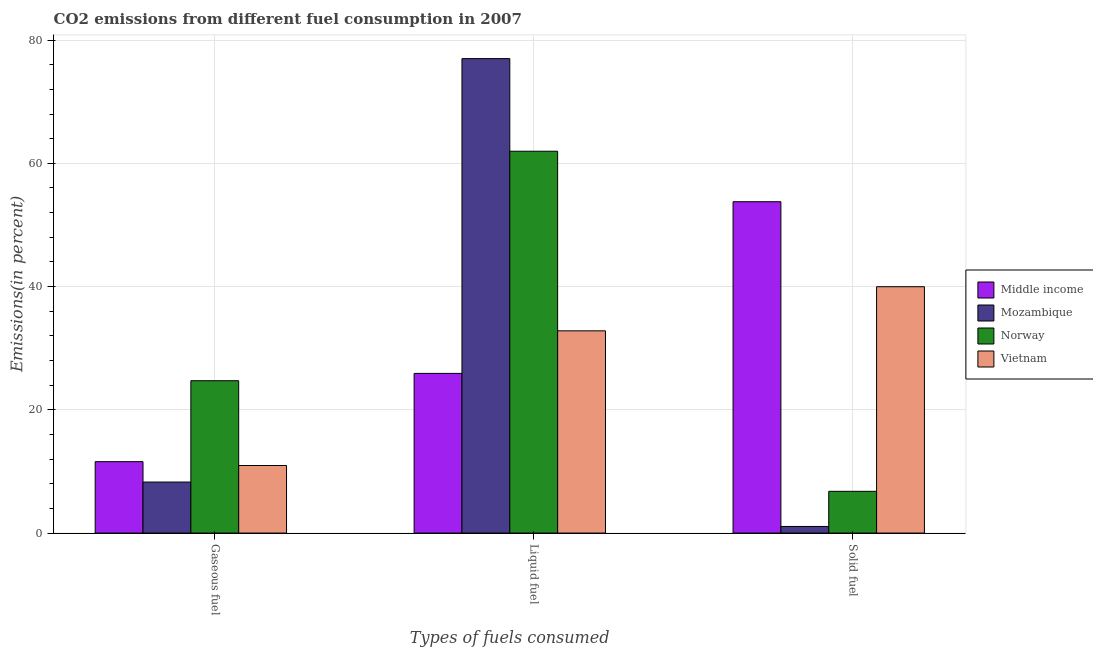How many different coloured bars are there?
Provide a succinct answer. 4. Are the number of bars on each tick of the X-axis equal?
Your answer should be compact. Yes. How many bars are there on the 2nd tick from the right?
Ensure brevity in your answer.  4. What is the label of the 1st group of bars from the left?
Offer a very short reply. Gaseous fuel. What is the percentage of liquid fuel emission in Middle income?
Your response must be concise. 25.91. Across all countries, what is the maximum percentage of liquid fuel emission?
Your answer should be very brief. 76.99. Across all countries, what is the minimum percentage of gaseous fuel emission?
Your response must be concise. 8.28. In which country was the percentage of solid fuel emission minimum?
Make the answer very short. Mozambique. What is the total percentage of gaseous fuel emission in the graph?
Give a very brief answer. 55.56. What is the difference between the percentage of solid fuel emission in Mozambique and that in Norway?
Offer a very short reply. -5.7. What is the difference between the percentage of solid fuel emission in Mozambique and the percentage of gaseous fuel emission in Vietnam?
Your answer should be compact. -9.89. What is the average percentage of liquid fuel emission per country?
Your answer should be compact. 49.42. What is the difference between the percentage of liquid fuel emission and percentage of gaseous fuel emission in Middle income?
Offer a very short reply. 14.32. In how many countries, is the percentage of solid fuel emission greater than 52 %?
Ensure brevity in your answer.  1. What is the ratio of the percentage of liquid fuel emission in Norway to that in Middle income?
Offer a terse response. 2.39. Is the percentage of liquid fuel emission in Middle income less than that in Mozambique?
Your answer should be very brief. Yes. Is the difference between the percentage of liquid fuel emission in Vietnam and Middle income greater than the difference between the percentage of solid fuel emission in Vietnam and Middle income?
Keep it short and to the point. Yes. What is the difference between the highest and the second highest percentage of gaseous fuel emission?
Offer a very short reply. 13.14. What is the difference between the highest and the lowest percentage of solid fuel emission?
Make the answer very short. 52.7. In how many countries, is the percentage of solid fuel emission greater than the average percentage of solid fuel emission taken over all countries?
Make the answer very short. 2. What does the 2nd bar from the left in Liquid fuel represents?
Your response must be concise. Mozambique. What does the 1st bar from the right in Gaseous fuel represents?
Ensure brevity in your answer.  Vietnam. Is it the case that in every country, the sum of the percentage of gaseous fuel emission and percentage of liquid fuel emission is greater than the percentage of solid fuel emission?
Your answer should be compact. No. How many bars are there?
Offer a terse response. 12. Are all the bars in the graph horizontal?
Make the answer very short. No. How many countries are there in the graph?
Ensure brevity in your answer.  4. What is the difference between two consecutive major ticks on the Y-axis?
Offer a terse response. 20. Does the graph contain any zero values?
Your answer should be very brief. No. Where does the legend appear in the graph?
Offer a very short reply. Center right. How many legend labels are there?
Your answer should be very brief. 4. How are the legend labels stacked?
Keep it short and to the point. Vertical. What is the title of the graph?
Provide a short and direct response. CO2 emissions from different fuel consumption in 2007. Does "China" appear as one of the legend labels in the graph?
Provide a short and direct response. No. What is the label or title of the X-axis?
Your response must be concise. Types of fuels consumed. What is the label or title of the Y-axis?
Provide a succinct answer. Emissions(in percent). What is the Emissions(in percent) of Middle income in Gaseous fuel?
Provide a succinct answer. 11.59. What is the Emissions(in percent) of Mozambique in Gaseous fuel?
Ensure brevity in your answer.  8.28. What is the Emissions(in percent) in Norway in Gaseous fuel?
Ensure brevity in your answer.  24.72. What is the Emissions(in percent) in Vietnam in Gaseous fuel?
Give a very brief answer. 10.96. What is the Emissions(in percent) of Middle income in Liquid fuel?
Provide a succinct answer. 25.91. What is the Emissions(in percent) in Mozambique in Liquid fuel?
Provide a succinct answer. 76.99. What is the Emissions(in percent) in Norway in Liquid fuel?
Your answer should be very brief. 61.96. What is the Emissions(in percent) in Vietnam in Liquid fuel?
Your answer should be compact. 32.82. What is the Emissions(in percent) in Middle income in Solid fuel?
Ensure brevity in your answer.  53.77. What is the Emissions(in percent) of Mozambique in Solid fuel?
Give a very brief answer. 1.07. What is the Emissions(in percent) of Norway in Solid fuel?
Keep it short and to the point. 6.77. What is the Emissions(in percent) of Vietnam in Solid fuel?
Offer a terse response. 39.98. Across all Types of fuels consumed, what is the maximum Emissions(in percent) of Middle income?
Keep it short and to the point. 53.77. Across all Types of fuels consumed, what is the maximum Emissions(in percent) in Mozambique?
Provide a succinct answer. 76.99. Across all Types of fuels consumed, what is the maximum Emissions(in percent) in Norway?
Your answer should be very brief. 61.96. Across all Types of fuels consumed, what is the maximum Emissions(in percent) in Vietnam?
Your answer should be compact. 39.98. Across all Types of fuels consumed, what is the minimum Emissions(in percent) in Middle income?
Provide a short and direct response. 11.59. Across all Types of fuels consumed, what is the minimum Emissions(in percent) of Mozambique?
Make the answer very short. 1.07. Across all Types of fuels consumed, what is the minimum Emissions(in percent) of Norway?
Keep it short and to the point. 6.77. Across all Types of fuels consumed, what is the minimum Emissions(in percent) of Vietnam?
Provide a short and direct response. 10.96. What is the total Emissions(in percent) of Middle income in the graph?
Provide a short and direct response. 91.27. What is the total Emissions(in percent) of Mozambique in the graph?
Your answer should be very brief. 86.35. What is the total Emissions(in percent) of Norway in the graph?
Provide a short and direct response. 93.46. What is the total Emissions(in percent) in Vietnam in the graph?
Your response must be concise. 83.76. What is the difference between the Emissions(in percent) of Middle income in Gaseous fuel and that in Liquid fuel?
Ensure brevity in your answer.  -14.32. What is the difference between the Emissions(in percent) of Mozambique in Gaseous fuel and that in Liquid fuel?
Provide a succinct answer. -68.71. What is the difference between the Emissions(in percent) in Norway in Gaseous fuel and that in Liquid fuel?
Give a very brief answer. -37.24. What is the difference between the Emissions(in percent) of Vietnam in Gaseous fuel and that in Liquid fuel?
Offer a very short reply. -21.85. What is the difference between the Emissions(in percent) in Middle income in Gaseous fuel and that in Solid fuel?
Ensure brevity in your answer.  -42.18. What is the difference between the Emissions(in percent) of Mozambique in Gaseous fuel and that in Solid fuel?
Keep it short and to the point. 7.21. What is the difference between the Emissions(in percent) in Norway in Gaseous fuel and that in Solid fuel?
Your response must be concise. 17.95. What is the difference between the Emissions(in percent) in Vietnam in Gaseous fuel and that in Solid fuel?
Your answer should be compact. -29.02. What is the difference between the Emissions(in percent) of Middle income in Liquid fuel and that in Solid fuel?
Your response must be concise. -27.86. What is the difference between the Emissions(in percent) in Mozambique in Liquid fuel and that in Solid fuel?
Ensure brevity in your answer.  75.92. What is the difference between the Emissions(in percent) of Norway in Liquid fuel and that in Solid fuel?
Your answer should be very brief. 55.19. What is the difference between the Emissions(in percent) of Vietnam in Liquid fuel and that in Solid fuel?
Keep it short and to the point. -7.16. What is the difference between the Emissions(in percent) of Middle income in Gaseous fuel and the Emissions(in percent) of Mozambique in Liquid fuel?
Make the answer very short. -65.41. What is the difference between the Emissions(in percent) in Middle income in Gaseous fuel and the Emissions(in percent) in Norway in Liquid fuel?
Keep it short and to the point. -50.38. What is the difference between the Emissions(in percent) in Middle income in Gaseous fuel and the Emissions(in percent) in Vietnam in Liquid fuel?
Offer a very short reply. -21.23. What is the difference between the Emissions(in percent) in Mozambique in Gaseous fuel and the Emissions(in percent) in Norway in Liquid fuel?
Ensure brevity in your answer.  -53.68. What is the difference between the Emissions(in percent) in Mozambique in Gaseous fuel and the Emissions(in percent) in Vietnam in Liquid fuel?
Keep it short and to the point. -24.54. What is the difference between the Emissions(in percent) of Norway in Gaseous fuel and the Emissions(in percent) of Vietnam in Liquid fuel?
Keep it short and to the point. -8.09. What is the difference between the Emissions(in percent) of Middle income in Gaseous fuel and the Emissions(in percent) of Mozambique in Solid fuel?
Make the answer very short. 10.51. What is the difference between the Emissions(in percent) in Middle income in Gaseous fuel and the Emissions(in percent) in Norway in Solid fuel?
Keep it short and to the point. 4.81. What is the difference between the Emissions(in percent) in Middle income in Gaseous fuel and the Emissions(in percent) in Vietnam in Solid fuel?
Give a very brief answer. -28.39. What is the difference between the Emissions(in percent) in Mozambique in Gaseous fuel and the Emissions(in percent) in Norway in Solid fuel?
Your answer should be compact. 1.51. What is the difference between the Emissions(in percent) in Mozambique in Gaseous fuel and the Emissions(in percent) in Vietnam in Solid fuel?
Give a very brief answer. -31.7. What is the difference between the Emissions(in percent) in Norway in Gaseous fuel and the Emissions(in percent) in Vietnam in Solid fuel?
Your answer should be compact. -15.26. What is the difference between the Emissions(in percent) of Middle income in Liquid fuel and the Emissions(in percent) of Mozambique in Solid fuel?
Make the answer very short. 24.84. What is the difference between the Emissions(in percent) in Middle income in Liquid fuel and the Emissions(in percent) in Norway in Solid fuel?
Provide a succinct answer. 19.14. What is the difference between the Emissions(in percent) of Middle income in Liquid fuel and the Emissions(in percent) of Vietnam in Solid fuel?
Offer a terse response. -14.07. What is the difference between the Emissions(in percent) of Mozambique in Liquid fuel and the Emissions(in percent) of Norway in Solid fuel?
Offer a terse response. 70.22. What is the difference between the Emissions(in percent) in Mozambique in Liquid fuel and the Emissions(in percent) in Vietnam in Solid fuel?
Make the answer very short. 37.02. What is the difference between the Emissions(in percent) in Norway in Liquid fuel and the Emissions(in percent) in Vietnam in Solid fuel?
Offer a very short reply. 21.98. What is the average Emissions(in percent) of Middle income per Types of fuels consumed?
Ensure brevity in your answer.  30.42. What is the average Emissions(in percent) of Mozambique per Types of fuels consumed?
Provide a short and direct response. 28.78. What is the average Emissions(in percent) of Norway per Types of fuels consumed?
Provide a succinct answer. 31.15. What is the average Emissions(in percent) in Vietnam per Types of fuels consumed?
Your answer should be very brief. 27.92. What is the difference between the Emissions(in percent) in Middle income and Emissions(in percent) in Mozambique in Gaseous fuel?
Give a very brief answer. 3.31. What is the difference between the Emissions(in percent) of Middle income and Emissions(in percent) of Norway in Gaseous fuel?
Give a very brief answer. -13.14. What is the difference between the Emissions(in percent) in Middle income and Emissions(in percent) in Vietnam in Gaseous fuel?
Make the answer very short. 0.62. What is the difference between the Emissions(in percent) of Mozambique and Emissions(in percent) of Norway in Gaseous fuel?
Provide a short and direct response. -16.44. What is the difference between the Emissions(in percent) in Mozambique and Emissions(in percent) in Vietnam in Gaseous fuel?
Ensure brevity in your answer.  -2.68. What is the difference between the Emissions(in percent) in Norway and Emissions(in percent) in Vietnam in Gaseous fuel?
Provide a short and direct response. 13.76. What is the difference between the Emissions(in percent) of Middle income and Emissions(in percent) of Mozambique in Liquid fuel?
Provide a succinct answer. -51.08. What is the difference between the Emissions(in percent) in Middle income and Emissions(in percent) in Norway in Liquid fuel?
Your answer should be very brief. -36.05. What is the difference between the Emissions(in percent) in Middle income and Emissions(in percent) in Vietnam in Liquid fuel?
Offer a terse response. -6.91. What is the difference between the Emissions(in percent) in Mozambique and Emissions(in percent) in Norway in Liquid fuel?
Ensure brevity in your answer.  15.03. What is the difference between the Emissions(in percent) in Mozambique and Emissions(in percent) in Vietnam in Liquid fuel?
Provide a succinct answer. 44.18. What is the difference between the Emissions(in percent) in Norway and Emissions(in percent) in Vietnam in Liquid fuel?
Provide a short and direct response. 29.15. What is the difference between the Emissions(in percent) in Middle income and Emissions(in percent) in Mozambique in Solid fuel?
Provide a succinct answer. 52.7. What is the difference between the Emissions(in percent) in Middle income and Emissions(in percent) in Norway in Solid fuel?
Give a very brief answer. 46.99. What is the difference between the Emissions(in percent) in Middle income and Emissions(in percent) in Vietnam in Solid fuel?
Provide a succinct answer. 13.79. What is the difference between the Emissions(in percent) of Mozambique and Emissions(in percent) of Norway in Solid fuel?
Make the answer very short. -5.7. What is the difference between the Emissions(in percent) in Mozambique and Emissions(in percent) in Vietnam in Solid fuel?
Your answer should be compact. -38.91. What is the difference between the Emissions(in percent) of Norway and Emissions(in percent) of Vietnam in Solid fuel?
Offer a very short reply. -33.2. What is the ratio of the Emissions(in percent) in Middle income in Gaseous fuel to that in Liquid fuel?
Provide a succinct answer. 0.45. What is the ratio of the Emissions(in percent) of Mozambique in Gaseous fuel to that in Liquid fuel?
Give a very brief answer. 0.11. What is the ratio of the Emissions(in percent) of Norway in Gaseous fuel to that in Liquid fuel?
Your answer should be very brief. 0.4. What is the ratio of the Emissions(in percent) of Vietnam in Gaseous fuel to that in Liquid fuel?
Provide a succinct answer. 0.33. What is the ratio of the Emissions(in percent) of Middle income in Gaseous fuel to that in Solid fuel?
Offer a terse response. 0.22. What is the ratio of the Emissions(in percent) of Mozambique in Gaseous fuel to that in Solid fuel?
Offer a terse response. 7.71. What is the ratio of the Emissions(in percent) in Norway in Gaseous fuel to that in Solid fuel?
Offer a very short reply. 3.65. What is the ratio of the Emissions(in percent) of Vietnam in Gaseous fuel to that in Solid fuel?
Your response must be concise. 0.27. What is the ratio of the Emissions(in percent) in Middle income in Liquid fuel to that in Solid fuel?
Make the answer very short. 0.48. What is the ratio of the Emissions(in percent) in Mozambique in Liquid fuel to that in Solid fuel?
Keep it short and to the point. 71.71. What is the ratio of the Emissions(in percent) of Norway in Liquid fuel to that in Solid fuel?
Your response must be concise. 9.15. What is the ratio of the Emissions(in percent) in Vietnam in Liquid fuel to that in Solid fuel?
Offer a terse response. 0.82. What is the difference between the highest and the second highest Emissions(in percent) of Middle income?
Provide a succinct answer. 27.86. What is the difference between the highest and the second highest Emissions(in percent) in Mozambique?
Offer a terse response. 68.71. What is the difference between the highest and the second highest Emissions(in percent) of Norway?
Keep it short and to the point. 37.24. What is the difference between the highest and the second highest Emissions(in percent) of Vietnam?
Your response must be concise. 7.16. What is the difference between the highest and the lowest Emissions(in percent) of Middle income?
Your response must be concise. 42.18. What is the difference between the highest and the lowest Emissions(in percent) in Mozambique?
Provide a succinct answer. 75.92. What is the difference between the highest and the lowest Emissions(in percent) in Norway?
Make the answer very short. 55.19. What is the difference between the highest and the lowest Emissions(in percent) in Vietnam?
Offer a terse response. 29.02. 